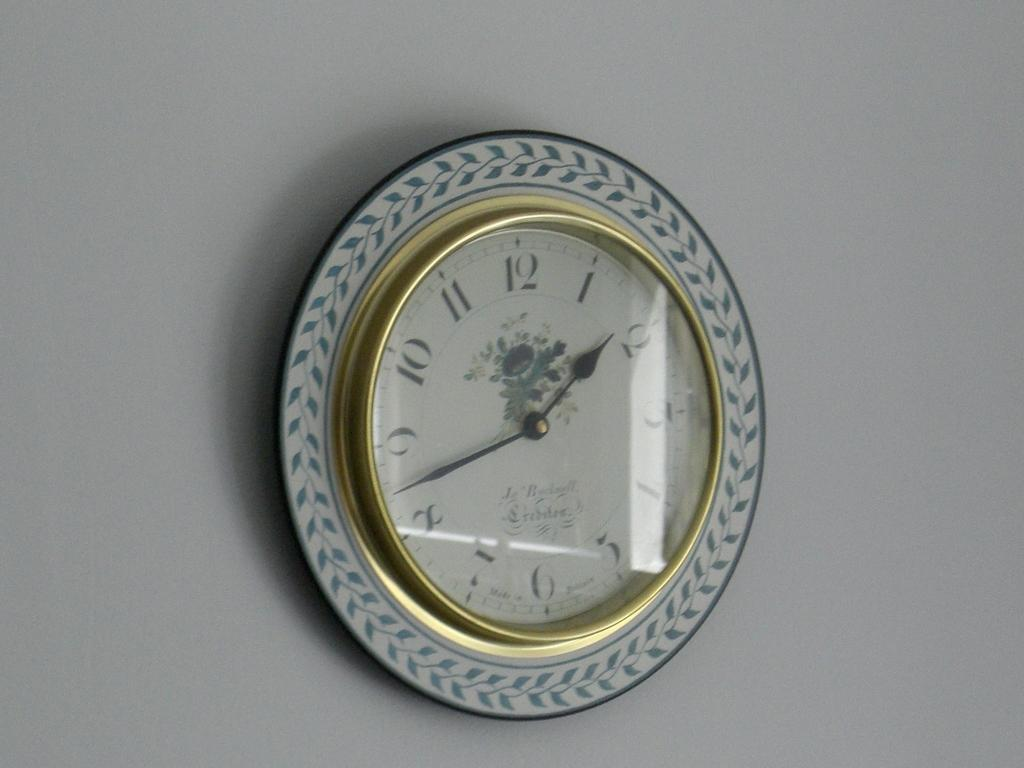<image>
Provide a brief description of the given image. A white and gold framed clock whose time reads 1:43 on its face. 